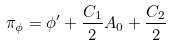<formula> <loc_0><loc_0><loc_500><loc_500>\pi _ { \phi } = \phi ^ { \prime } + \frac { C _ { 1 } } { 2 } A _ { 0 } + \frac { C _ { 2 } } { 2 }</formula> 